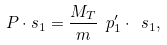<formula> <loc_0><loc_0><loc_500><loc_500>P \cdot s _ { 1 } = \frac { M _ { T } } { m } \ p ^ { \prime } _ { 1 } \cdot \ s _ { 1 } ,</formula> 